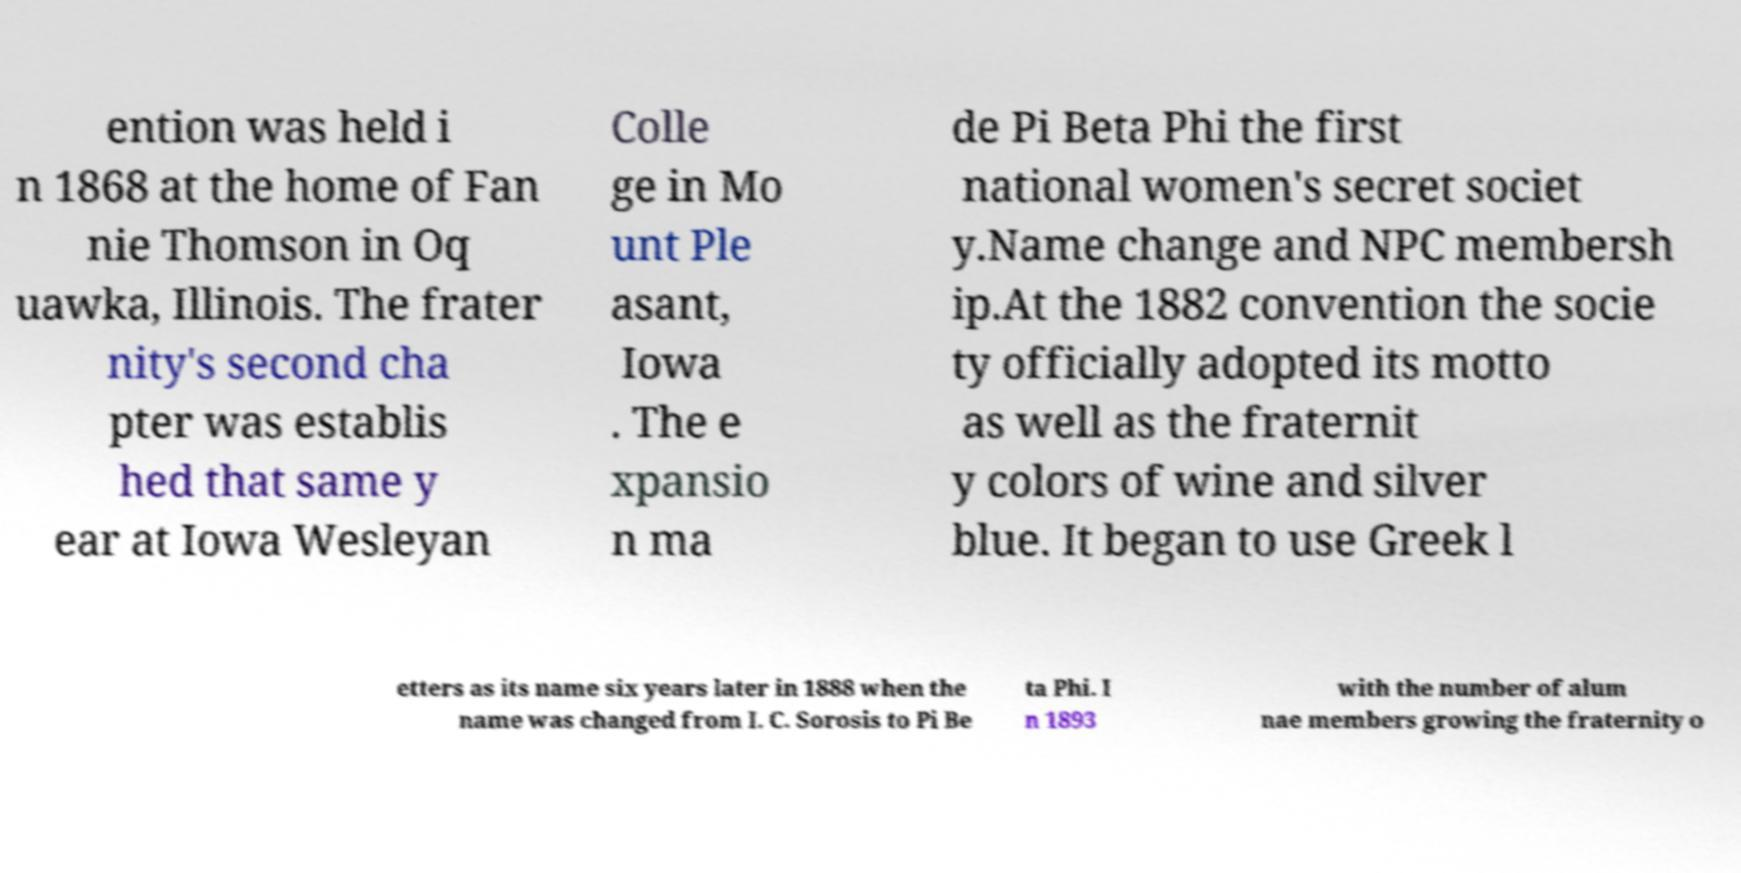Can you accurately transcribe the text from the provided image for me? ention was held i n 1868 at the home of Fan nie Thomson in Oq uawka, Illinois. The frater nity's second cha pter was establis hed that same y ear at Iowa Wesleyan Colle ge in Mo unt Ple asant, Iowa . The e xpansio n ma de Pi Beta Phi the first national women's secret societ y.Name change and NPC membersh ip.At the 1882 convention the socie ty officially adopted its motto as well as the fraternit y colors of wine and silver blue. It began to use Greek l etters as its name six years later in 1888 when the name was changed from I. C. Sorosis to Pi Be ta Phi. I n 1893 with the number of alum nae members growing the fraternity o 